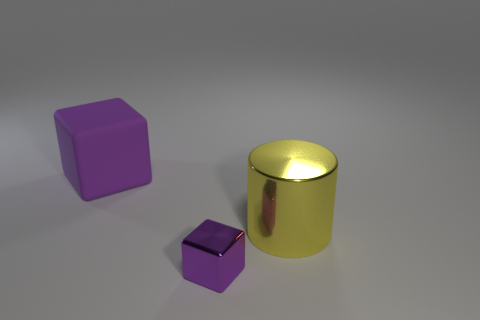Is the color of the metal cube the same as the large rubber cube? Yes, both objects appear to share a similar shade of purple. Although their materials are different, which can affect perception of color due to light reflection and texture, the base color of both cubes seems to match. 